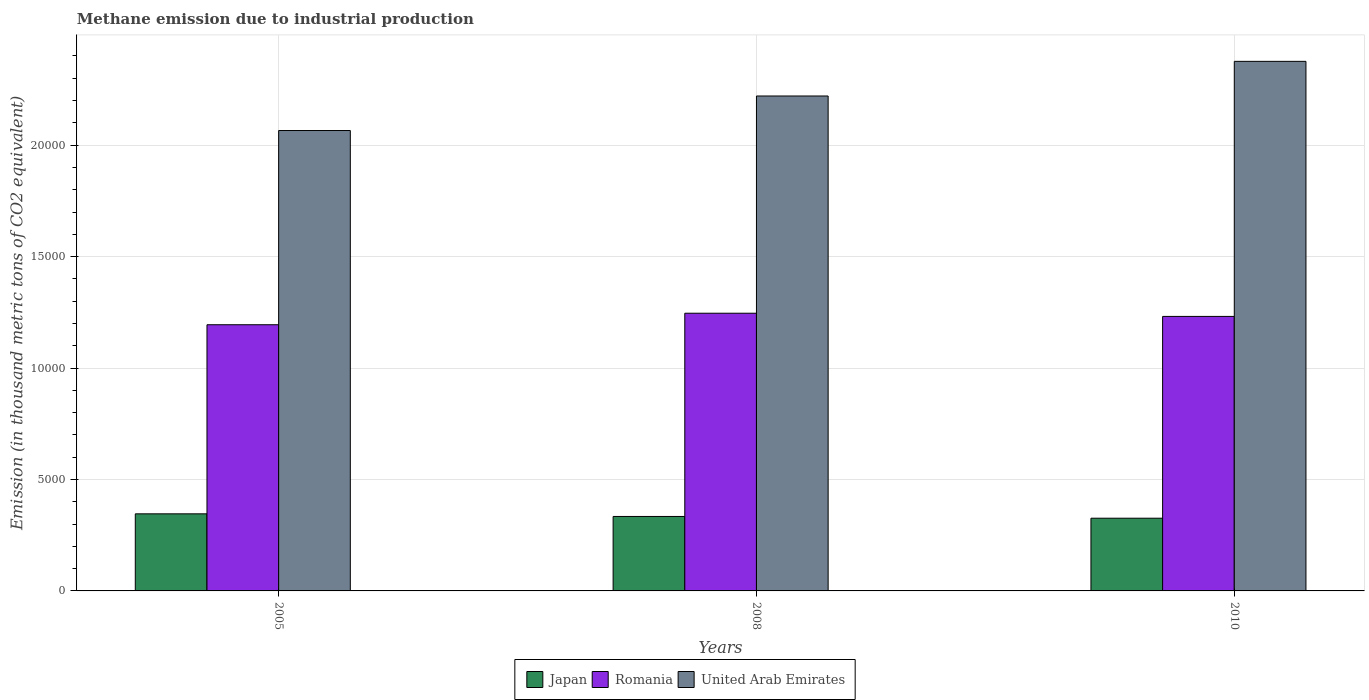How many different coloured bars are there?
Provide a succinct answer. 3. How many bars are there on the 2nd tick from the right?
Give a very brief answer. 3. In how many cases, is the number of bars for a given year not equal to the number of legend labels?
Offer a very short reply. 0. What is the amount of methane emitted in United Arab Emirates in 2010?
Give a very brief answer. 2.38e+04. Across all years, what is the maximum amount of methane emitted in Romania?
Your response must be concise. 1.25e+04. Across all years, what is the minimum amount of methane emitted in Japan?
Keep it short and to the point. 3262. What is the total amount of methane emitted in Japan in the graph?
Your answer should be compact. 1.01e+04. What is the difference between the amount of methane emitted in Romania in 2005 and that in 2010?
Offer a very short reply. -373.2. What is the difference between the amount of methane emitted in Japan in 2008 and the amount of methane emitted in United Arab Emirates in 2005?
Give a very brief answer. -1.73e+04. What is the average amount of methane emitted in Romania per year?
Your response must be concise. 1.22e+04. In the year 2008, what is the difference between the amount of methane emitted in United Arab Emirates and amount of methane emitted in Japan?
Offer a very short reply. 1.89e+04. What is the ratio of the amount of methane emitted in Romania in 2005 to that in 2008?
Your answer should be very brief. 0.96. Is the amount of methane emitted in Japan in 2005 less than that in 2010?
Give a very brief answer. No. Is the difference between the amount of methane emitted in United Arab Emirates in 2005 and 2008 greater than the difference between the amount of methane emitted in Japan in 2005 and 2008?
Provide a short and direct response. No. What is the difference between the highest and the second highest amount of methane emitted in United Arab Emirates?
Offer a terse response. 1554. What is the difference between the highest and the lowest amount of methane emitted in Romania?
Give a very brief answer. 516.5. Is the sum of the amount of methane emitted in Japan in 2005 and 2010 greater than the maximum amount of methane emitted in United Arab Emirates across all years?
Make the answer very short. No. What does the 3rd bar from the right in 2010 represents?
Give a very brief answer. Japan. Is it the case that in every year, the sum of the amount of methane emitted in Japan and amount of methane emitted in United Arab Emirates is greater than the amount of methane emitted in Romania?
Your answer should be compact. Yes. How many years are there in the graph?
Your answer should be compact. 3. What is the difference between two consecutive major ticks on the Y-axis?
Give a very brief answer. 5000. Are the values on the major ticks of Y-axis written in scientific E-notation?
Make the answer very short. No. Does the graph contain any zero values?
Give a very brief answer. No. What is the title of the graph?
Provide a short and direct response. Methane emission due to industrial production. Does "Micronesia" appear as one of the legend labels in the graph?
Ensure brevity in your answer.  No. What is the label or title of the Y-axis?
Provide a short and direct response. Emission (in thousand metric tons of CO2 equivalent). What is the Emission (in thousand metric tons of CO2 equivalent) of Japan in 2005?
Ensure brevity in your answer.  3458.3. What is the Emission (in thousand metric tons of CO2 equivalent) in Romania in 2005?
Keep it short and to the point. 1.19e+04. What is the Emission (in thousand metric tons of CO2 equivalent) in United Arab Emirates in 2005?
Provide a succinct answer. 2.07e+04. What is the Emission (in thousand metric tons of CO2 equivalent) in Japan in 2008?
Offer a very short reply. 3341. What is the Emission (in thousand metric tons of CO2 equivalent) in Romania in 2008?
Keep it short and to the point. 1.25e+04. What is the Emission (in thousand metric tons of CO2 equivalent) in United Arab Emirates in 2008?
Keep it short and to the point. 2.22e+04. What is the Emission (in thousand metric tons of CO2 equivalent) in Japan in 2010?
Make the answer very short. 3262. What is the Emission (in thousand metric tons of CO2 equivalent) in Romania in 2010?
Provide a succinct answer. 1.23e+04. What is the Emission (in thousand metric tons of CO2 equivalent) in United Arab Emirates in 2010?
Offer a terse response. 2.38e+04. Across all years, what is the maximum Emission (in thousand metric tons of CO2 equivalent) of Japan?
Keep it short and to the point. 3458.3. Across all years, what is the maximum Emission (in thousand metric tons of CO2 equivalent) of Romania?
Provide a short and direct response. 1.25e+04. Across all years, what is the maximum Emission (in thousand metric tons of CO2 equivalent) in United Arab Emirates?
Your answer should be compact. 2.38e+04. Across all years, what is the minimum Emission (in thousand metric tons of CO2 equivalent) in Japan?
Your answer should be compact. 3262. Across all years, what is the minimum Emission (in thousand metric tons of CO2 equivalent) of Romania?
Your response must be concise. 1.19e+04. Across all years, what is the minimum Emission (in thousand metric tons of CO2 equivalent) in United Arab Emirates?
Make the answer very short. 2.07e+04. What is the total Emission (in thousand metric tons of CO2 equivalent) in Japan in the graph?
Your answer should be compact. 1.01e+04. What is the total Emission (in thousand metric tons of CO2 equivalent) of Romania in the graph?
Your answer should be very brief. 3.67e+04. What is the total Emission (in thousand metric tons of CO2 equivalent) in United Arab Emirates in the graph?
Your answer should be compact. 6.66e+04. What is the difference between the Emission (in thousand metric tons of CO2 equivalent) in Japan in 2005 and that in 2008?
Offer a terse response. 117.3. What is the difference between the Emission (in thousand metric tons of CO2 equivalent) of Romania in 2005 and that in 2008?
Offer a terse response. -516.5. What is the difference between the Emission (in thousand metric tons of CO2 equivalent) in United Arab Emirates in 2005 and that in 2008?
Make the answer very short. -1549. What is the difference between the Emission (in thousand metric tons of CO2 equivalent) in Japan in 2005 and that in 2010?
Provide a short and direct response. 196.3. What is the difference between the Emission (in thousand metric tons of CO2 equivalent) of Romania in 2005 and that in 2010?
Your answer should be very brief. -373.2. What is the difference between the Emission (in thousand metric tons of CO2 equivalent) in United Arab Emirates in 2005 and that in 2010?
Give a very brief answer. -3103. What is the difference between the Emission (in thousand metric tons of CO2 equivalent) of Japan in 2008 and that in 2010?
Your answer should be very brief. 79. What is the difference between the Emission (in thousand metric tons of CO2 equivalent) in Romania in 2008 and that in 2010?
Make the answer very short. 143.3. What is the difference between the Emission (in thousand metric tons of CO2 equivalent) in United Arab Emirates in 2008 and that in 2010?
Offer a terse response. -1554. What is the difference between the Emission (in thousand metric tons of CO2 equivalent) of Japan in 2005 and the Emission (in thousand metric tons of CO2 equivalent) of Romania in 2008?
Ensure brevity in your answer.  -9000.6. What is the difference between the Emission (in thousand metric tons of CO2 equivalent) of Japan in 2005 and the Emission (in thousand metric tons of CO2 equivalent) of United Arab Emirates in 2008?
Offer a terse response. -1.87e+04. What is the difference between the Emission (in thousand metric tons of CO2 equivalent) of Romania in 2005 and the Emission (in thousand metric tons of CO2 equivalent) of United Arab Emirates in 2008?
Your response must be concise. -1.03e+04. What is the difference between the Emission (in thousand metric tons of CO2 equivalent) of Japan in 2005 and the Emission (in thousand metric tons of CO2 equivalent) of Romania in 2010?
Give a very brief answer. -8857.3. What is the difference between the Emission (in thousand metric tons of CO2 equivalent) in Japan in 2005 and the Emission (in thousand metric tons of CO2 equivalent) in United Arab Emirates in 2010?
Offer a terse response. -2.03e+04. What is the difference between the Emission (in thousand metric tons of CO2 equivalent) in Romania in 2005 and the Emission (in thousand metric tons of CO2 equivalent) in United Arab Emirates in 2010?
Give a very brief answer. -1.18e+04. What is the difference between the Emission (in thousand metric tons of CO2 equivalent) in Japan in 2008 and the Emission (in thousand metric tons of CO2 equivalent) in Romania in 2010?
Offer a terse response. -8974.6. What is the difference between the Emission (in thousand metric tons of CO2 equivalent) in Japan in 2008 and the Emission (in thousand metric tons of CO2 equivalent) in United Arab Emirates in 2010?
Your answer should be very brief. -2.04e+04. What is the difference between the Emission (in thousand metric tons of CO2 equivalent) in Romania in 2008 and the Emission (in thousand metric tons of CO2 equivalent) in United Arab Emirates in 2010?
Offer a terse response. -1.13e+04. What is the average Emission (in thousand metric tons of CO2 equivalent) of Japan per year?
Make the answer very short. 3353.77. What is the average Emission (in thousand metric tons of CO2 equivalent) in Romania per year?
Your answer should be very brief. 1.22e+04. What is the average Emission (in thousand metric tons of CO2 equivalent) in United Arab Emirates per year?
Offer a terse response. 2.22e+04. In the year 2005, what is the difference between the Emission (in thousand metric tons of CO2 equivalent) of Japan and Emission (in thousand metric tons of CO2 equivalent) of Romania?
Your answer should be very brief. -8484.1. In the year 2005, what is the difference between the Emission (in thousand metric tons of CO2 equivalent) in Japan and Emission (in thousand metric tons of CO2 equivalent) in United Arab Emirates?
Provide a succinct answer. -1.72e+04. In the year 2005, what is the difference between the Emission (in thousand metric tons of CO2 equivalent) of Romania and Emission (in thousand metric tons of CO2 equivalent) of United Arab Emirates?
Keep it short and to the point. -8713.9. In the year 2008, what is the difference between the Emission (in thousand metric tons of CO2 equivalent) in Japan and Emission (in thousand metric tons of CO2 equivalent) in Romania?
Ensure brevity in your answer.  -9117.9. In the year 2008, what is the difference between the Emission (in thousand metric tons of CO2 equivalent) in Japan and Emission (in thousand metric tons of CO2 equivalent) in United Arab Emirates?
Offer a very short reply. -1.89e+04. In the year 2008, what is the difference between the Emission (in thousand metric tons of CO2 equivalent) of Romania and Emission (in thousand metric tons of CO2 equivalent) of United Arab Emirates?
Make the answer very short. -9746.4. In the year 2010, what is the difference between the Emission (in thousand metric tons of CO2 equivalent) in Japan and Emission (in thousand metric tons of CO2 equivalent) in Romania?
Your answer should be compact. -9053.6. In the year 2010, what is the difference between the Emission (in thousand metric tons of CO2 equivalent) in Japan and Emission (in thousand metric tons of CO2 equivalent) in United Arab Emirates?
Give a very brief answer. -2.05e+04. In the year 2010, what is the difference between the Emission (in thousand metric tons of CO2 equivalent) of Romania and Emission (in thousand metric tons of CO2 equivalent) of United Arab Emirates?
Keep it short and to the point. -1.14e+04. What is the ratio of the Emission (in thousand metric tons of CO2 equivalent) of Japan in 2005 to that in 2008?
Offer a very short reply. 1.04. What is the ratio of the Emission (in thousand metric tons of CO2 equivalent) in Romania in 2005 to that in 2008?
Make the answer very short. 0.96. What is the ratio of the Emission (in thousand metric tons of CO2 equivalent) in United Arab Emirates in 2005 to that in 2008?
Give a very brief answer. 0.93. What is the ratio of the Emission (in thousand metric tons of CO2 equivalent) of Japan in 2005 to that in 2010?
Provide a succinct answer. 1.06. What is the ratio of the Emission (in thousand metric tons of CO2 equivalent) of Romania in 2005 to that in 2010?
Your answer should be compact. 0.97. What is the ratio of the Emission (in thousand metric tons of CO2 equivalent) in United Arab Emirates in 2005 to that in 2010?
Offer a terse response. 0.87. What is the ratio of the Emission (in thousand metric tons of CO2 equivalent) of Japan in 2008 to that in 2010?
Offer a very short reply. 1.02. What is the ratio of the Emission (in thousand metric tons of CO2 equivalent) of Romania in 2008 to that in 2010?
Provide a succinct answer. 1.01. What is the ratio of the Emission (in thousand metric tons of CO2 equivalent) of United Arab Emirates in 2008 to that in 2010?
Your response must be concise. 0.93. What is the difference between the highest and the second highest Emission (in thousand metric tons of CO2 equivalent) of Japan?
Ensure brevity in your answer.  117.3. What is the difference between the highest and the second highest Emission (in thousand metric tons of CO2 equivalent) in Romania?
Your answer should be compact. 143.3. What is the difference between the highest and the second highest Emission (in thousand metric tons of CO2 equivalent) in United Arab Emirates?
Your answer should be compact. 1554. What is the difference between the highest and the lowest Emission (in thousand metric tons of CO2 equivalent) of Japan?
Provide a succinct answer. 196.3. What is the difference between the highest and the lowest Emission (in thousand metric tons of CO2 equivalent) in Romania?
Your answer should be very brief. 516.5. What is the difference between the highest and the lowest Emission (in thousand metric tons of CO2 equivalent) of United Arab Emirates?
Offer a very short reply. 3103. 